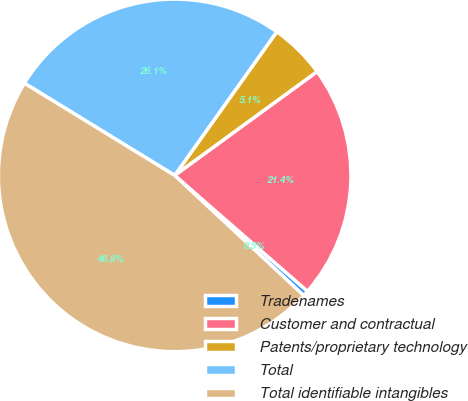<chart> <loc_0><loc_0><loc_500><loc_500><pie_chart><fcel>Tradenames<fcel>Customer and contractual<fcel>Patents/proprietary technology<fcel>Total<fcel>Total identifiable intangibles<nl><fcel>0.51%<fcel>21.44%<fcel>5.14%<fcel>26.08%<fcel>46.83%<nl></chart> 